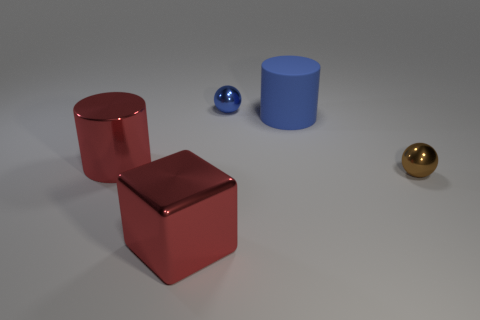There is a small blue thing that is the same shape as the brown object; what material is it?
Make the answer very short. Metal. Are there an equal number of tiny blue shiny objects in front of the cube and tiny brown shiny things on the left side of the tiny brown ball?
Your answer should be very brief. Yes. There is a object that is behind the blue rubber cylinder; does it have the same shape as the tiny brown object?
Your answer should be compact. Yes. The tiny thing left of the cylinder that is right of the metal object that is on the left side of the big red block is what shape?
Keep it short and to the point. Sphere. What is the shape of the metal object that is the same color as the cube?
Your answer should be compact. Cylinder. The object that is right of the large red cylinder and to the left of the tiny blue shiny object is made of what material?
Your answer should be very brief. Metal. Is the number of large brown matte cylinders less than the number of rubber cylinders?
Your answer should be compact. Yes. Is the shape of the big rubber thing the same as the thing behind the matte thing?
Offer a terse response. No. There is a blue object that is on the right side of the blue shiny sphere; is its size the same as the tiny brown thing?
Ensure brevity in your answer.  No. What is the shape of the metallic object that is the same size as the shiny cylinder?
Make the answer very short. Cube. 